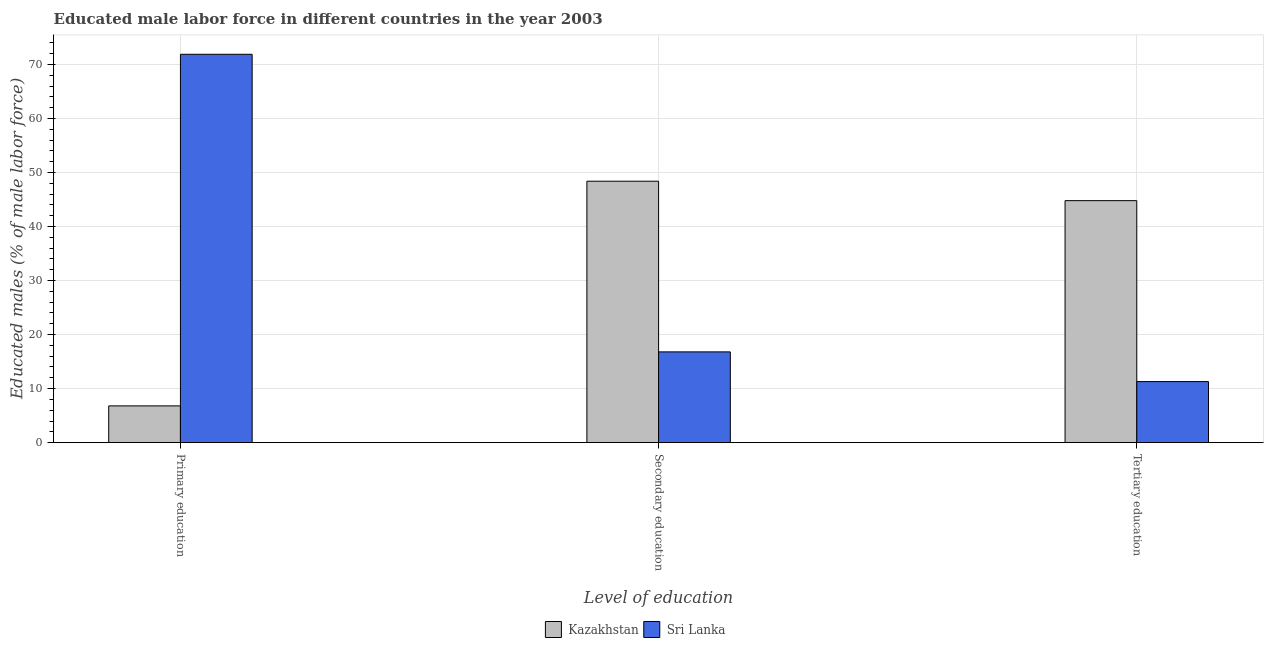How many groups of bars are there?
Your answer should be compact. 3. Are the number of bars per tick equal to the number of legend labels?
Make the answer very short. Yes. How many bars are there on the 1st tick from the right?
Give a very brief answer. 2. What is the label of the 2nd group of bars from the left?
Make the answer very short. Secondary education. What is the percentage of male labor force who received secondary education in Sri Lanka?
Offer a very short reply. 16.8. Across all countries, what is the maximum percentage of male labor force who received tertiary education?
Make the answer very short. 44.8. Across all countries, what is the minimum percentage of male labor force who received secondary education?
Give a very brief answer. 16.8. In which country was the percentage of male labor force who received secondary education maximum?
Ensure brevity in your answer.  Kazakhstan. In which country was the percentage of male labor force who received tertiary education minimum?
Provide a succinct answer. Sri Lanka. What is the total percentage of male labor force who received secondary education in the graph?
Offer a terse response. 65.2. What is the difference between the percentage of male labor force who received secondary education in Sri Lanka and that in Kazakhstan?
Ensure brevity in your answer.  -31.6. What is the difference between the percentage of male labor force who received primary education in Sri Lanka and the percentage of male labor force who received secondary education in Kazakhstan?
Provide a short and direct response. 23.5. What is the average percentage of male labor force who received secondary education per country?
Provide a succinct answer. 32.6. What is the difference between the percentage of male labor force who received tertiary education and percentage of male labor force who received secondary education in Kazakhstan?
Provide a short and direct response. -3.6. What is the ratio of the percentage of male labor force who received primary education in Sri Lanka to that in Kazakhstan?
Ensure brevity in your answer.  10.57. Is the difference between the percentage of male labor force who received secondary education in Sri Lanka and Kazakhstan greater than the difference between the percentage of male labor force who received primary education in Sri Lanka and Kazakhstan?
Provide a succinct answer. No. What is the difference between the highest and the second highest percentage of male labor force who received tertiary education?
Keep it short and to the point. 33.5. What is the difference between the highest and the lowest percentage of male labor force who received primary education?
Ensure brevity in your answer.  65.1. In how many countries, is the percentage of male labor force who received tertiary education greater than the average percentage of male labor force who received tertiary education taken over all countries?
Provide a short and direct response. 1. Is the sum of the percentage of male labor force who received primary education in Sri Lanka and Kazakhstan greater than the maximum percentage of male labor force who received tertiary education across all countries?
Provide a succinct answer. Yes. What does the 1st bar from the left in Secondary education represents?
Offer a very short reply. Kazakhstan. What does the 2nd bar from the right in Primary education represents?
Provide a short and direct response. Kazakhstan. How many countries are there in the graph?
Provide a succinct answer. 2. What is the difference between two consecutive major ticks on the Y-axis?
Your answer should be compact. 10. Does the graph contain grids?
Your response must be concise. Yes. Where does the legend appear in the graph?
Provide a succinct answer. Bottom center. How many legend labels are there?
Make the answer very short. 2. What is the title of the graph?
Keep it short and to the point. Educated male labor force in different countries in the year 2003. Does "Singapore" appear as one of the legend labels in the graph?
Offer a very short reply. No. What is the label or title of the X-axis?
Make the answer very short. Level of education. What is the label or title of the Y-axis?
Ensure brevity in your answer.  Educated males (% of male labor force). What is the Educated males (% of male labor force) in Kazakhstan in Primary education?
Offer a very short reply. 6.8. What is the Educated males (% of male labor force) of Sri Lanka in Primary education?
Ensure brevity in your answer.  71.9. What is the Educated males (% of male labor force) in Kazakhstan in Secondary education?
Your answer should be very brief. 48.4. What is the Educated males (% of male labor force) of Sri Lanka in Secondary education?
Offer a very short reply. 16.8. What is the Educated males (% of male labor force) in Kazakhstan in Tertiary education?
Your answer should be compact. 44.8. What is the Educated males (% of male labor force) in Sri Lanka in Tertiary education?
Offer a very short reply. 11.3. Across all Level of education, what is the maximum Educated males (% of male labor force) of Kazakhstan?
Give a very brief answer. 48.4. Across all Level of education, what is the maximum Educated males (% of male labor force) in Sri Lanka?
Provide a short and direct response. 71.9. Across all Level of education, what is the minimum Educated males (% of male labor force) of Kazakhstan?
Keep it short and to the point. 6.8. Across all Level of education, what is the minimum Educated males (% of male labor force) in Sri Lanka?
Offer a terse response. 11.3. What is the total Educated males (% of male labor force) of Kazakhstan in the graph?
Your response must be concise. 100. What is the difference between the Educated males (% of male labor force) of Kazakhstan in Primary education and that in Secondary education?
Your answer should be very brief. -41.6. What is the difference between the Educated males (% of male labor force) in Sri Lanka in Primary education and that in Secondary education?
Make the answer very short. 55.1. What is the difference between the Educated males (% of male labor force) of Kazakhstan in Primary education and that in Tertiary education?
Offer a terse response. -38. What is the difference between the Educated males (% of male labor force) in Sri Lanka in Primary education and that in Tertiary education?
Keep it short and to the point. 60.6. What is the difference between the Educated males (% of male labor force) in Sri Lanka in Secondary education and that in Tertiary education?
Offer a very short reply. 5.5. What is the difference between the Educated males (% of male labor force) in Kazakhstan in Primary education and the Educated males (% of male labor force) in Sri Lanka in Secondary education?
Your response must be concise. -10. What is the difference between the Educated males (% of male labor force) of Kazakhstan in Secondary education and the Educated males (% of male labor force) of Sri Lanka in Tertiary education?
Ensure brevity in your answer.  37.1. What is the average Educated males (% of male labor force) of Kazakhstan per Level of education?
Your answer should be very brief. 33.33. What is the average Educated males (% of male labor force) of Sri Lanka per Level of education?
Ensure brevity in your answer.  33.33. What is the difference between the Educated males (% of male labor force) in Kazakhstan and Educated males (% of male labor force) in Sri Lanka in Primary education?
Offer a very short reply. -65.1. What is the difference between the Educated males (% of male labor force) of Kazakhstan and Educated males (% of male labor force) of Sri Lanka in Secondary education?
Keep it short and to the point. 31.6. What is the difference between the Educated males (% of male labor force) of Kazakhstan and Educated males (% of male labor force) of Sri Lanka in Tertiary education?
Keep it short and to the point. 33.5. What is the ratio of the Educated males (% of male labor force) of Kazakhstan in Primary education to that in Secondary education?
Your answer should be compact. 0.14. What is the ratio of the Educated males (% of male labor force) in Sri Lanka in Primary education to that in Secondary education?
Your answer should be very brief. 4.28. What is the ratio of the Educated males (% of male labor force) of Kazakhstan in Primary education to that in Tertiary education?
Provide a succinct answer. 0.15. What is the ratio of the Educated males (% of male labor force) of Sri Lanka in Primary education to that in Tertiary education?
Give a very brief answer. 6.36. What is the ratio of the Educated males (% of male labor force) in Kazakhstan in Secondary education to that in Tertiary education?
Offer a terse response. 1.08. What is the ratio of the Educated males (% of male labor force) of Sri Lanka in Secondary education to that in Tertiary education?
Ensure brevity in your answer.  1.49. What is the difference between the highest and the second highest Educated males (% of male labor force) in Sri Lanka?
Provide a short and direct response. 55.1. What is the difference between the highest and the lowest Educated males (% of male labor force) of Kazakhstan?
Keep it short and to the point. 41.6. What is the difference between the highest and the lowest Educated males (% of male labor force) of Sri Lanka?
Your answer should be very brief. 60.6. 